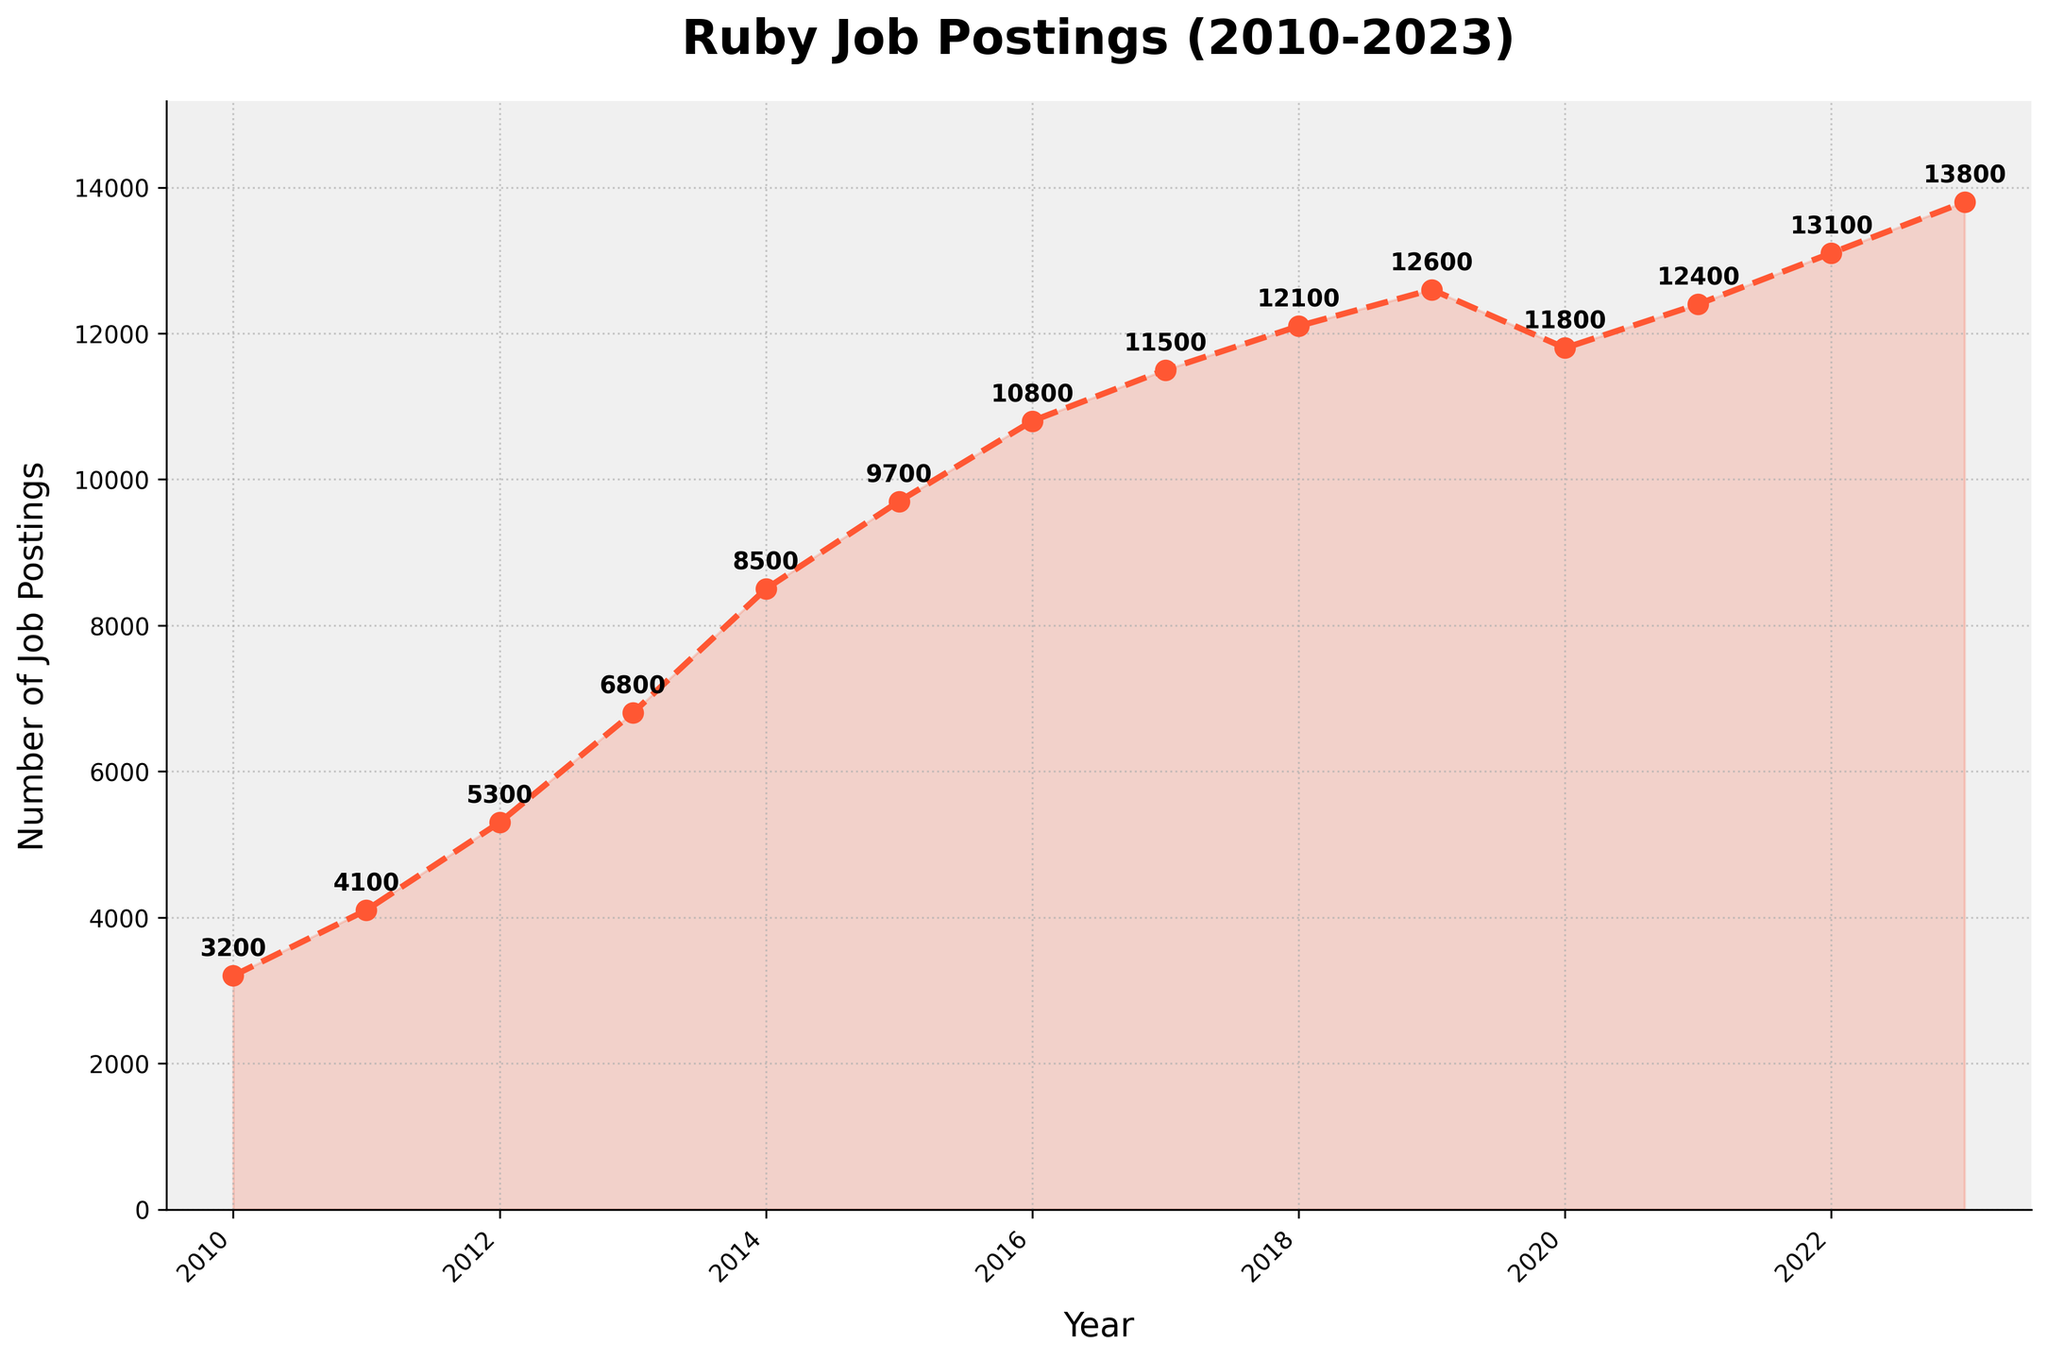What is the number of Ruby job postings in 2013? Look at the plotted data point for the year 2013. The value is marked beside the corresponding point.
Answer: 6800 Which year had the highest number of Ruby job postings? Find the peak point on the graph and identify the year at which it occurs. The highest point is in 2023.
Answer: 2023 How much did the number of Ruby job postings increase from 2010 to 2023? Subtract the number of job postings in 2010 from the number of job postings in 2023 (13800 - 3200).
Answer: 10600 In which year did the number of Ruby job postings first exceed 10000? Look at the plotted data points and identify the first year where the value crosses 10000. This occurred in 2016.
Answer: 2016 What is the average number of Ruby job postings from 2010 to 2023? Sum all the values from each year and divide by the number of years (14). The sum is 110,700, and the average is 110700/14.
Answer: 7907.14 Between which consecutive years was the largest increase in Ruby job postings observed? Calculate the difference between consecutive years and identify the largest increase. The largest increase is from 2013 to 2014 (8500 - 6800 = 1700).
Answer: 2013 to 2014 What trend can be observed in the number of Ruby job postings from 2019 to 2020? Check the data points for 2019 and 2020 and observe the change. There is a decrease from 2019 to 2020 (12600 to 11800).
Answer: Decrease How many years show a consistent increasing trend in job postings without any drop? Count the number of years where the number of job postings increased consecutively. From 2010 to 2019, the postings increased each year.
Answer: 9 years What is the percentage increase in Ruby job postings from 2018 to 2023? Calculate the difference and then find the percentage increase based on the 2018 value [(13800 - 12100) / 12100 * 100].
Answer: 14.05% Describe the visual trend of the job postings from 2010 to 2023. Observe the overall shape of the line graph, noting significant increases, decreases, and plateaus. The trend shows a general increase with a slight dip around 2020.
Answer: Generally increasing with a dip around 2020 